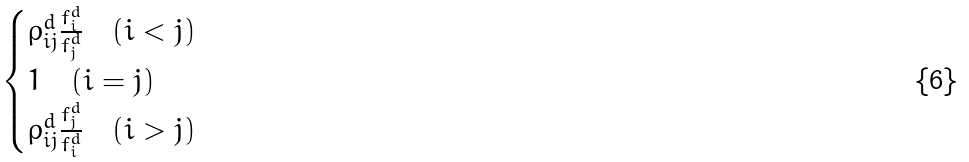Convert formula to latex. <formula><loc_0><loc_0><loc_500><loc_500>\begin{cases} \rho ^ { d } _ { i j } \frac { f ^ { d } _ { i } } { f ^ { d } _ { j } } \quad ( i < j ) \\ 1 \quad ( i = j ) \\ \rho ^ { d } _ { i j } \frac { f ^ { d } _ { j } } { f ^ { d } _ { i } } \quad ( i > j ) \end{cases}</formula> 